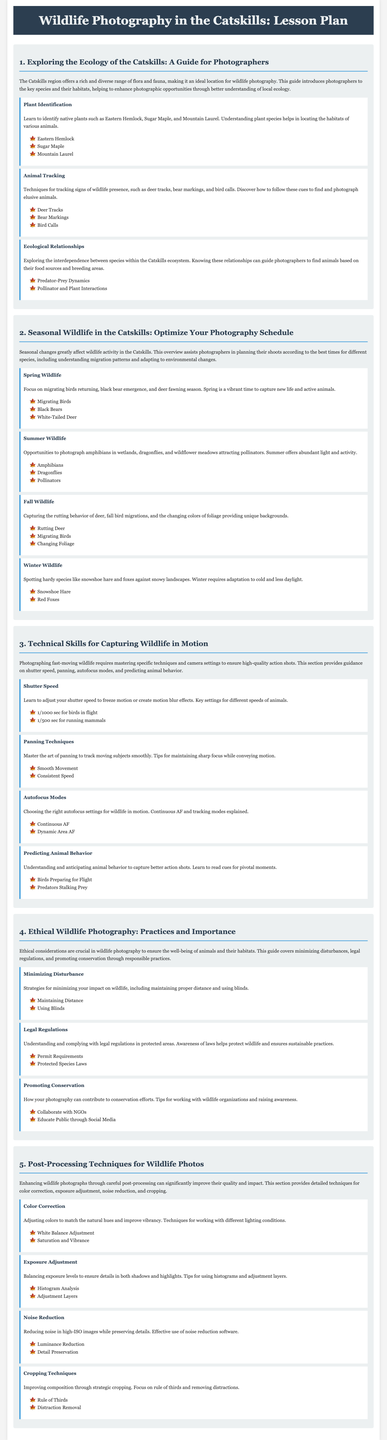What is the title of the lesson plan? The title summarizing the document is presented at the top of the header section.
Answer: Wildlife Photography in the Catskills: Lesson Plan How many main lessons are included in the lesson plan? The document outlines the total number of primary lessons focusing on various aspects of wildlife photography.
Answer: 5 Which module discusses strategies for minimizing disturbance? The specific module addressing this topic is found in the section on ethical practices in wildlife photography.
Answer: Minimizing Disturbance What is a key species that is tracked in the Animal Tracking module? This module emphasizes particular animal signs that wildlife photographers should recognize and follow.
Answer: Deer Tracks What shutter speed is suggested for photographing birds in flight? This specific setting is provided within the technical skills section for capturing wildlife motion effectively.
Answer: 1/1000 sec What is described in the Spring Wildlife module? This module includes details about the wildlife activity typical during the spring season in the Catskills.
Answer: Migrating Birds Which technique is emphasized for improving composition in post-processing? The lesson on cropping techniques details a specific guideline for enhancing photographic composition.
Answer: Rule of Thirds What does the Color Correction module focus on? This module discusses methods to adjust the colors in wildlife photographs.
Answer: Adjusting colors Which animal is noted for its emergence in Spring? The lesson plan includes information about the behavior of a specific species during the spring season.
Answer: Black Bears 